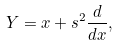<formula> <loc_0><loc_0><loc_500><loc_500>Y = x + s ^ { 2 } \frac { d } { d x } ,</formula> 